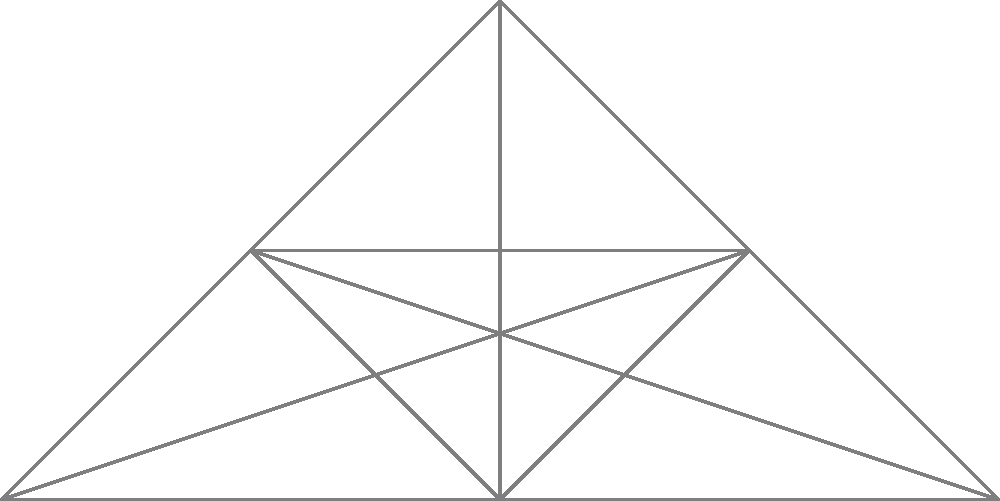Analyze the network diagram representing interconnected human beliefs and their environmental impact. Which belief, if significantly reduced, would likely have the most substantial positive effect on environmental sustainability, and why? To answer this question, we need to consider the following steps:

1. Examine the network structure:
   The diagram shows six interconnected beliefs: Consumerism, Individualism, Materialism, Anthropocentrism, Technological Optimism, and Economic Growth.

2. Analyze the connections:
   All beliefs are interconnected, suggesting that they influence and reinforce each other.

3. Observe the environmental impact:
   All beliefs are connected to the "Environmental Impact" node, indicating that each contributes to environmental issues.

4. Consider the nature of each belief:
   - Consumerism: Encourages excessive consumption of goods and resources.
   - Individualism: Prioritizes individual interests over collective well-being.
   - Materialism: Values material possessions and wealth accumulation.
   - Anthropocentrism: Places human needs and desires above other species and ecosystems.
   - Technological Optimism: Overreliance on technology to solve environmental problems.
   - Economic Growth: Prioritizes continuous economic expansion, often at the expense of the environment.

5. Evaluate the potential impact of reducing each belief:
   Reducing consumerism would likely have the most substantial positive effect on environmental sustainability because:
   a) It directly drives resource depletion and waste production.
   b) It fuels economic growth, which often conflicts with environmental protection.
   c) It reinforces materialism and individualism, which can lead to unsustainable practices.
   d) It often relies on technological optimism to justify continued consumption.
   e) It frequently disregards the needs of other species and ecosystems (anthropocentrism).

6. Consider the cascading effects:
   Reducing consumerism could lead to a decrease in materialism, a shift away from anthropocentrism, and a reevaluation of economic growth models, potentially creating a positive feedback loop for environmental sustainability.
Answer: Consumerism 